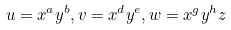<formula> <loc_0><loc_0><loc_500><loc_500>u = x ^ { a } y ^ { b } , v = x ^ { d } y ^ { e } , w = x ^ { g } y ^ { h } z</formula> 